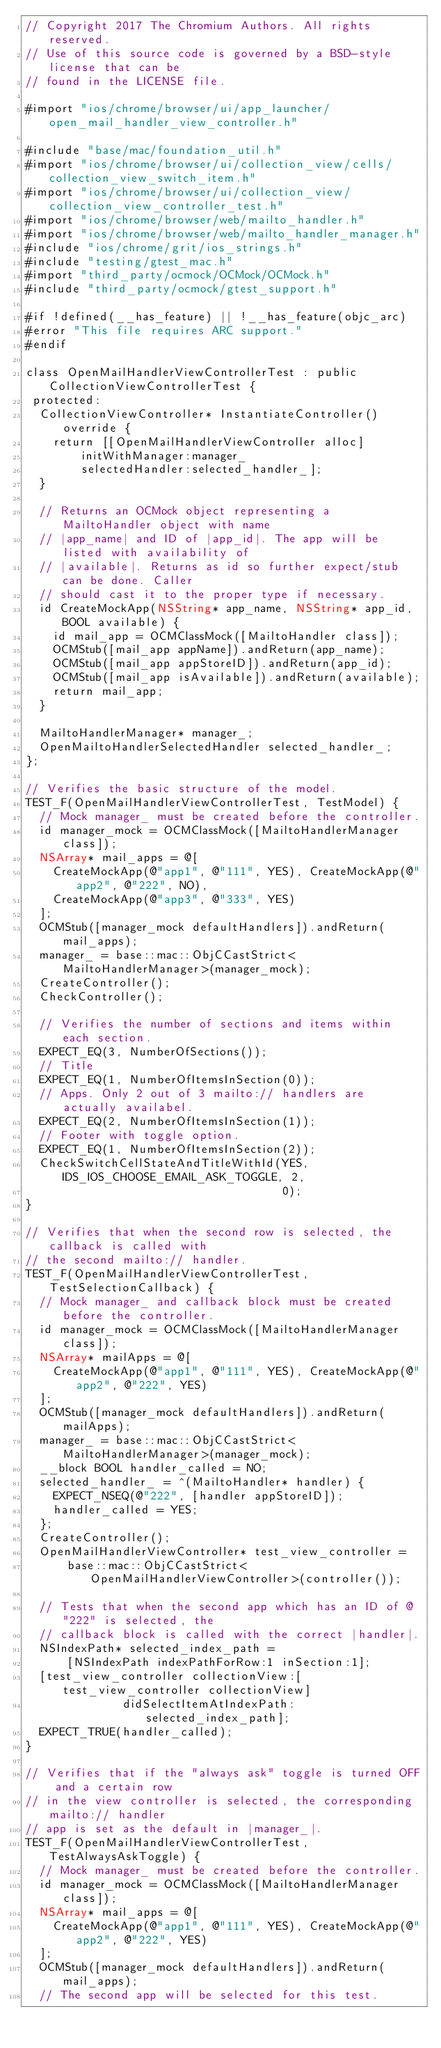<code> <loc_0><loc_0><loc_500><loc_500><_ObjectiveC_>// Copyright 2017 The Chromium Authors. All rights reserved.
// Use of this source code is governed by a BSD-style license that can be
// found in the LICENSE file.

#import "ios/chrome/browser/ui/app_launcher/open_mail_handler_view_controller.h"

#include "base/mac/foundation_util.h"
#import "ios/chrome/browser/ui/collection_view/cells/collection_view_switch_item.h"
#import "ios/chrome/browser/ui/collection_view/collection_view_controller_test.h"
#import "ios/chrome/browser/web/mailto_handler.h"
#import "ios/chrome/browser/web/mailto_handler_manager.h"
#include "ios/chrome/grit/ios_strings.h"
#include "testing/gtest_mac.h"
#import "third_party/ocmock/OCMock/OCMock.h"
#include "third_party/ocmock/gtest_support.h"

#if !defined(__has_feature) || !__has_feature(objc_arc)
#error "This file requires ARC support."
#endif

class OpenMailHandlerViewControllerTest : public CollectionViewControllerTest {
 protected:
  CollectionViewController* InstantiateController() override {
    return [[OpenMailHandlerViewController alloc]
        initWithManager:manager_
        selectedHandler:selected_handler_];
  }

  // Returns an OCMock object representing a MailtoHandler object with name
  // |app_name| and ID of |app_id|. The app will be listed with availability of
  // |available|. Returns as id so further expect/stub can be done. Caller
  // should cast it to the proper type if necessary.
  id CreateMockApp(NSString* app_name, NSString* app_id, BOOL available) {
    id mail_app = OCMClassMock([MailtoHandler class]);
    OCMStub([mail_app appName]).andReturn(app_name);
    OCMStub([mail_app appStoreID]).andReturn(app_id);
    OCMStub([mail_app isAvailable]).andReturn(available);
    return mail_app;
  }

  MailtoHandlerManager* manager_;
  OpenMailtoHandlerSelectedHandler selected_handler_;
};

// Verifies the basic structure of the model.
TEST_F(OpenMailHandlerViewControllerTest, TestModel) {
  // Mock manager_ must be created before the controller.
  id manager_mock = OCMClassMock([MailtoHandlerManager class]);
  NSArray* mail_apps = @[
    CreateMockApp(@"app1", @"111", YES), CreateMockApp(@"app2", @"222", NO),
    CreateMockApp(@"app3", @"333", YES)
  ];
  OCMStub([manager_mock defaultHandlers]).andReturn(mail_apps);
  manager_ = base::mac::ObjCCastStrict<MailtoHandlerManager>(manager_mock);
  CreateController();
  CheckController();

  // Verifies the number of sections and items within each section.
  EXPECT_EQ(3, NumberOfSections());
  // Title
  EXPECT_EQ(1, NumberOfItemsInSection(0));
  // Apps. Only 2 out of 3 mailto:// handlers are actually availabel.
  EXPECT_EQ(2, NumberOfItemsInSection(1));
  // Footer with toggle option.
  EXPECT_EQ(1, NumberOfItemsInSection(2));
  CheckSwitchCellStateAndTitleWithId(YES, IDS_IOS_CHOOSE_EMAIL_ASK_TOGGLE, 2,
                                     0);
}

// Verifies that when the second row is selected, the callback is called with
// the second mailto:// handler.
TEST_F(OpenMailHandlerViewControllerTest, TestSelectionCallback) {
  // Mock manager_ and callback block must be created before the controller.
  id manager_mock = OCMClassMock([MailtoHandlerManager class]);
  NSArray* mailApps = @[
    CreateMockApp(@"app1", @"111", YES), CreateMockApp(@"app2", @"222", YES)
  ];
  OCMStub([manager_mock defaultHandlers]).andReturn(mailApps);
  manager_ = base::mac::ObjCCastStrict<MailtoHandlerManager>(manager_mock);
  __block BOOL handler_called = NO;
  selected_handler_ = ^(MailtoHandler* handler) {
    EXPECT_NSEQ(@"222", [handler appStoreID]);
    handler_called = YES;
  };
  CreateController();
  OpenMailHandlerViewController* test_view_controller =
      base::mac::ObjCCastStrict<OpenMailHandlerViewController>(controller());

  // Tests that when the second app which has an ID of @"222" is selected, the
  // callback block is called with the correct |handler|.
  NSIndexPath* selected_index_path =
      [NSIndexPath indexPathForRow:1 inSection:1];
  [test_view_controller collectionView:[test_view_controller collectionView]
              didSelectItemAtIndexPath:selected_index_path];
  EXPECT_TRUE(handler_called);
}

// Verifies that if the "always ask" toggle is turned OFF and a certain row
// in the view controller is selected, the corresponding mailto:// handler
// app is set as the default in |manager_|.
TEST_F(OpenMailHandlerViewControllerTest, TestAlwaysAskToggle) {
  // Mock manager_ must be created before the controller.
  id manager_mock = OCMClassMock([MailtoHandlerManager class]);
  NSArray* mail_apps = @[
    CreateMockApp(@"app1", @"111", YES), CreateMockApp(@"app2", @"222", YES)
  ];
  OCMStub([manager_mock defaultHandlers]).andReturn(mail_apps);
  // The second app will be selected for this test.</code> 